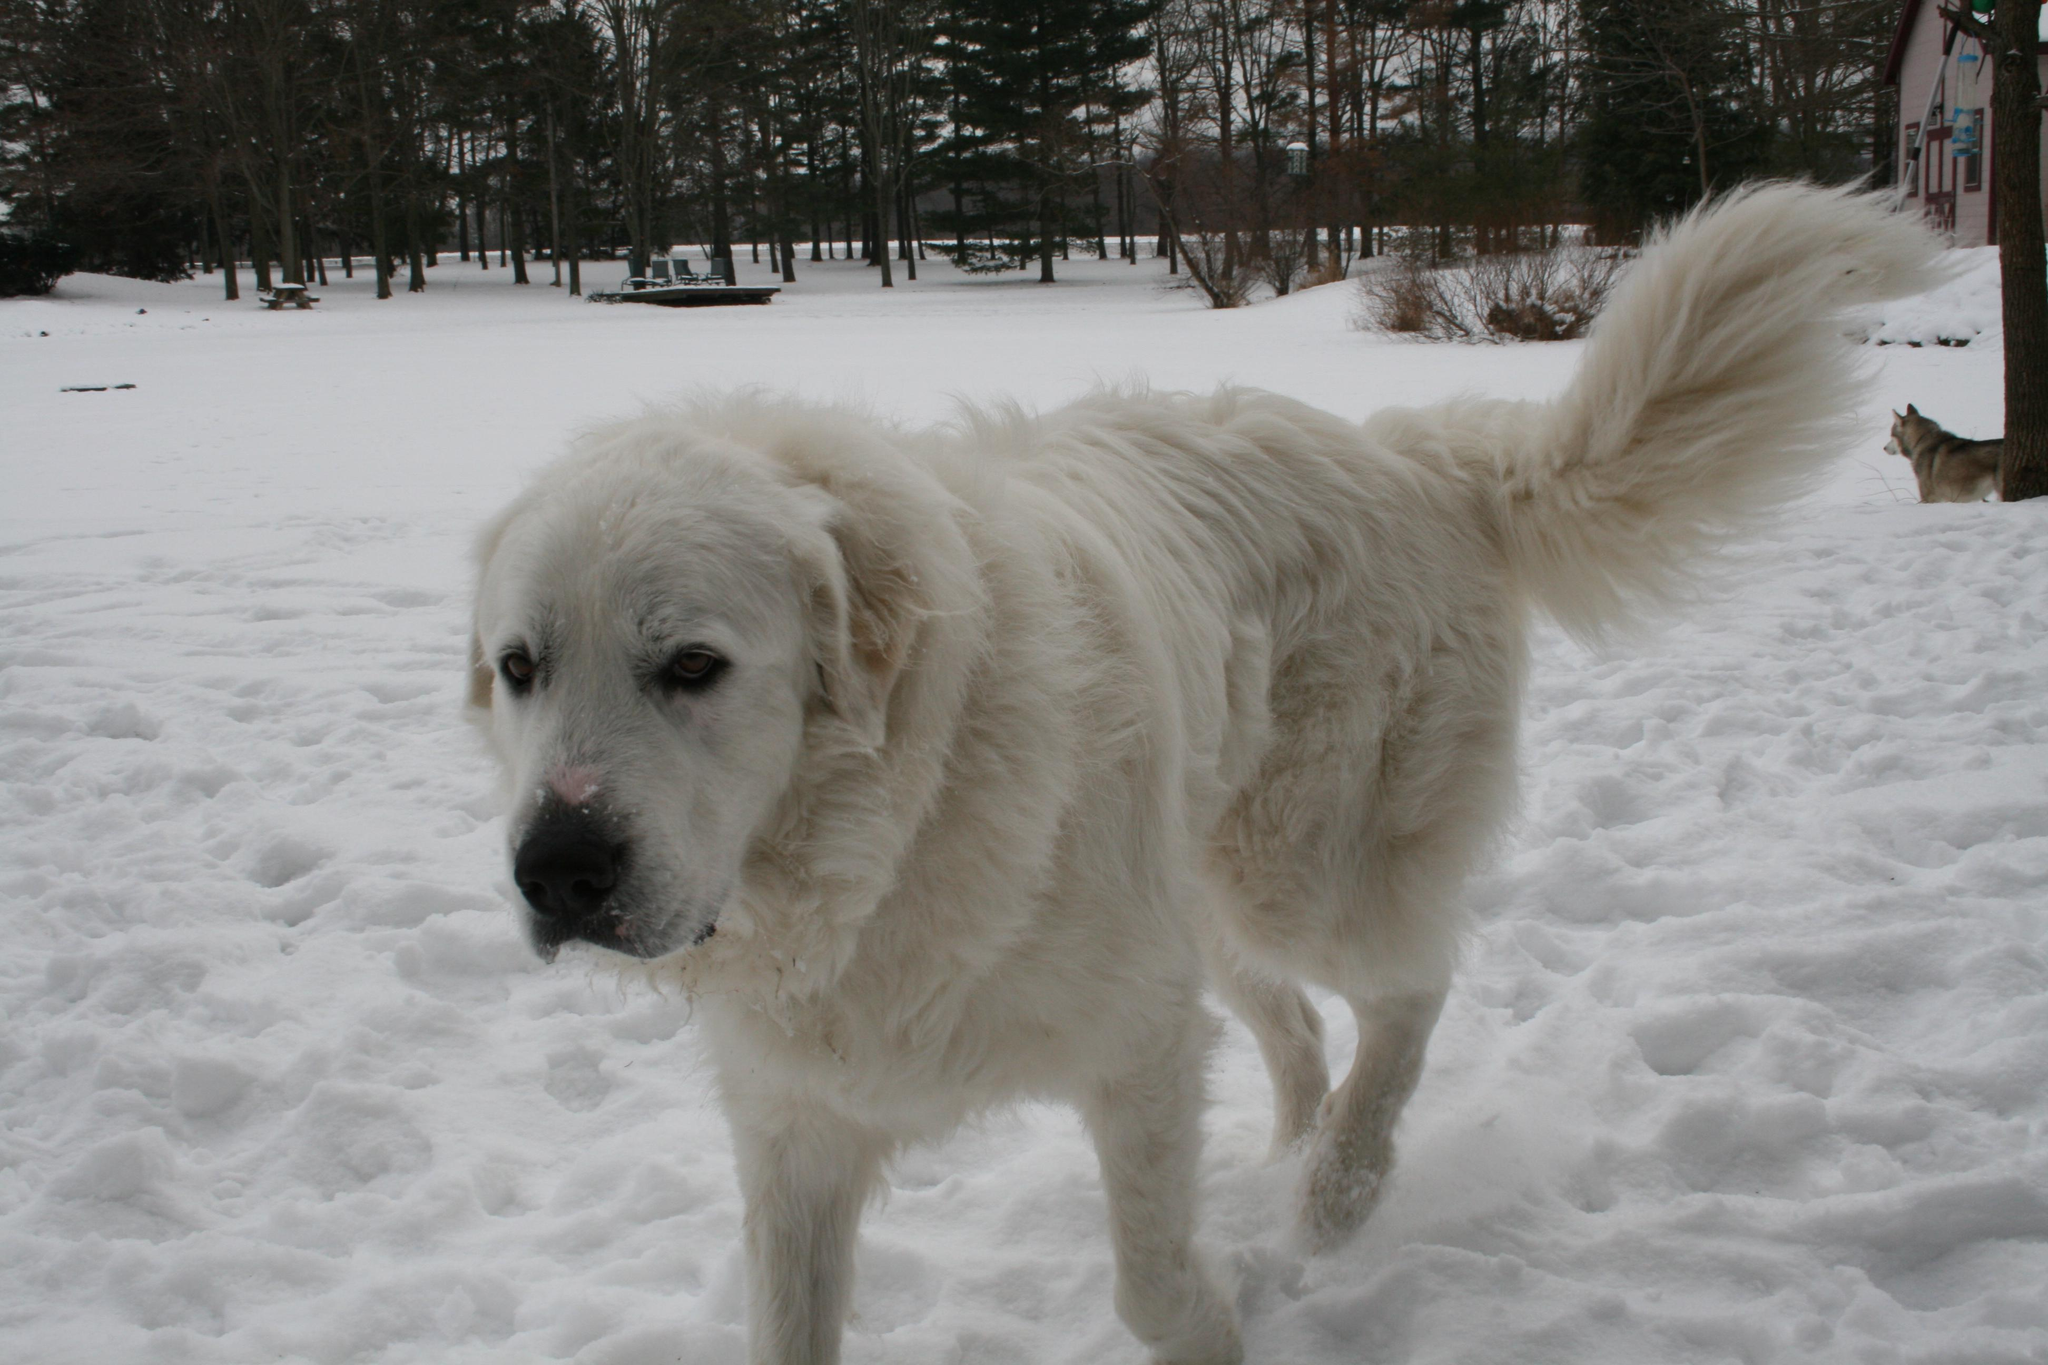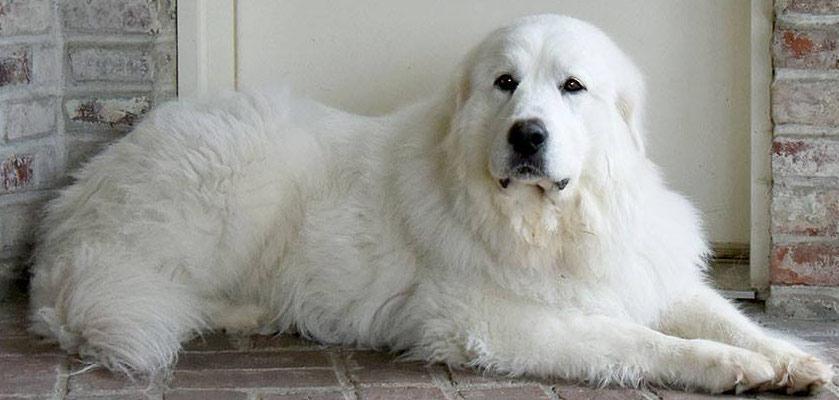The first image is the image on the left, the second image is the image on the right. Evaluate the accuracy of this statement regarding the images: "An image shows a fluffy dog reclining on the grass.". Is it true? Answer yes or no. No. 